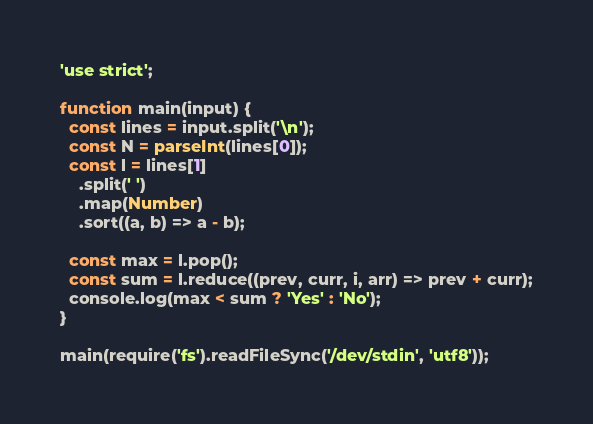Convert code to text. <code><loc_0><loc_0><loc_500><loc_500><_JavaScript_>'use strict';

function main(input) {
  const lines = input.split('\n');
  const N = parseInt(lines[0]);
  const l = lines[1]
    .split(' ')
    .map(Number)
    .sort((a, b) => a - b);

  const max = l.pop();
  const sum = l.reduce((prev, curr, i, arr) => prev + curr);
  console.log(max < sum ? 'Yes' : 'No');
}

main(require('fs').readFileSync('/dev/stdin', 'utf8'));
</code> 